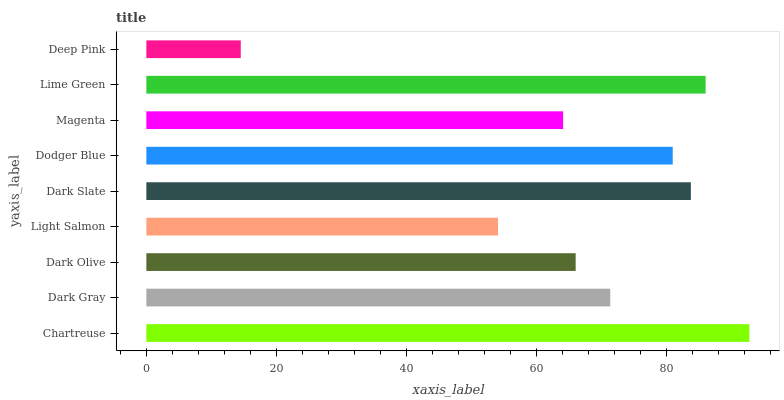Is Deep Pink the minimum?
Answer yes or no. Yes. Is Chartreuse the maximum?
Answer yes or no. Yes. Is Dark Gray the minimum?
Answer yes or no. No. Is Dark Gray the maximum?
Answer yes or no. No. Is Chartreuse greater than Dark Gray?
Answer yes or no. Yes. Is Dark Gray less than Chartreuse?
Answer yes or no. Yes. Is Dark Gray greater than Chartreuse?
Answer yes or no. No. Is Chartreuse less than Dark Gray?
Answer yes or no. No. Is Dark Gray the high median?
Answer yes or no. Yes. Is Dark Gray the low median?
Answer yes or no. Yes. Is Deep Pink the high median?
Answer yes or no. No. Is Chartreuse the low median?
Answer yes or no. No. 